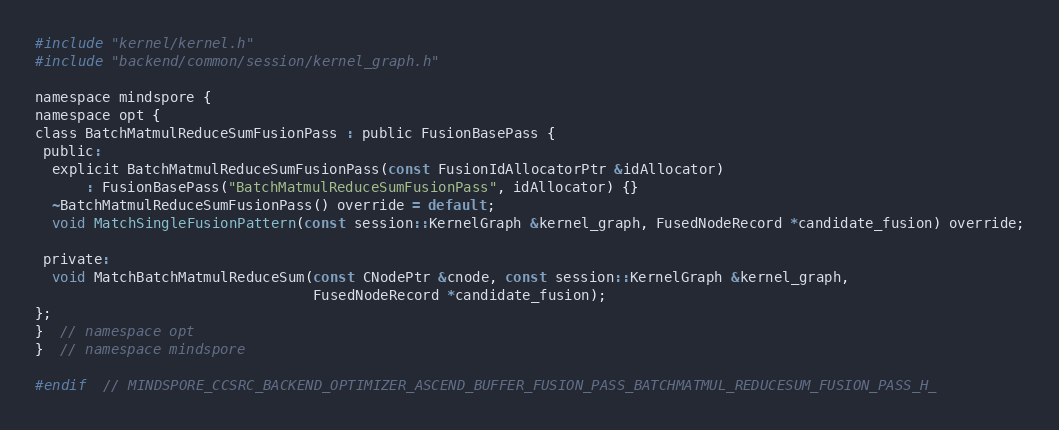<code> <loc_0><loc_0><loc_500><loc_500><_C_>#include "kernel/kernel.h"
#include "backend/common/session/kernel_graph.h"

namespace mindspore {
namespace opt {
class BatchMatmulReduceSumFusionPass : public FusionBasePass {
 public:
  explicit BatchMatmulReduceSumFusionPass(const FusionIdAllocatorPtr &idAllocator)
      : FusionBasePass("BatchMatmulReduceSumFusionPass", idAllocator) {}
  ~BatchMatmulReduceSumFusionPass() override = default;
  void MatchSingleFusionPattern(const session::KernelGraph &kernel_graph, FusedNodeRecord *candidate_fusion) override;

 private:
  void MatchBatchMatmulReduceSum(const CNodePtr &cnode, const session::KernelGraph &kernel_graph,
                                 FusedNodeRecord *candidate_fusion);
};
}  // namespace opt
}  // namespace mindspore

#endif  // MINDSPORE_CCSRC_BACKEND_OPTIMIZER_ASCEND_BUFFER_FUSION_PASS_BATCHMATMUL_REDUCESUM_FUSION_PASS_H_
</code> 